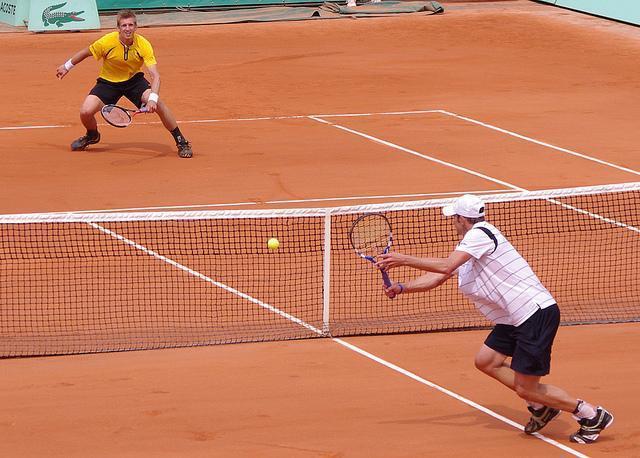How many people can be seen?
Give a very brief answer. 2. 